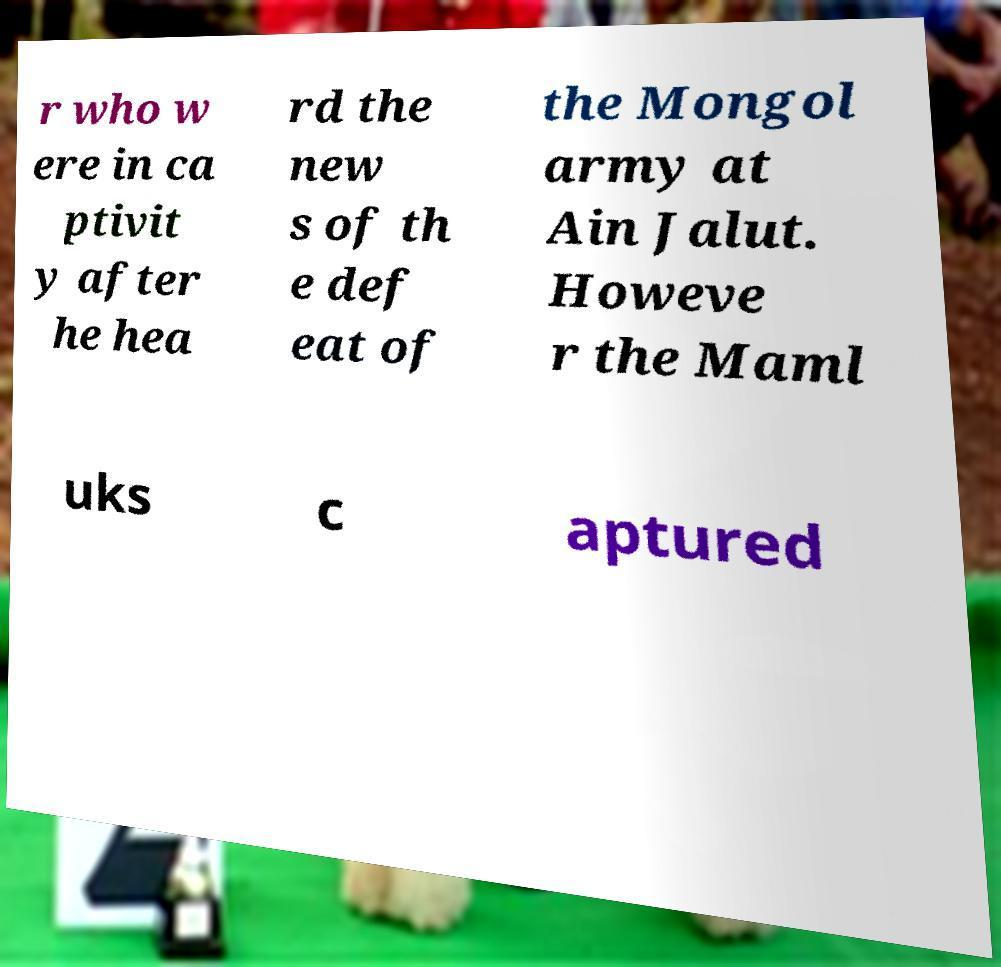Could you assist in decoding the text presented in this image and type it out clearly? r who w ere in ca ptivit y after he hea rd the new s of th e def eat of the Mongol army at Ain Jalut. Howeve r the Maml uks c aptured 